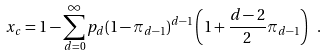Convert formula to latex. <formula><loc_0><loc_0><loc_500><loc_500>x _ { c } = 1 - \sum _ { d = 0 } ^ { \infty } p _ { d } ( 1 - \pi _ { d - 1 } ) ^ { d - 1 } \left ( 1 + \frac { d - 2 } 2 \pi _ { d - 1 } \right ) \ .</formula> 